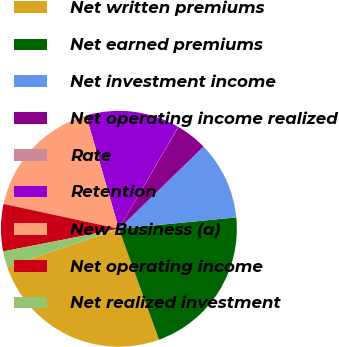<chart> <loc_0><loc_0><loc_500><loc_500><pie_chart><fcel>Net written premiums<fcel>Net earned premiums<fcel>Net investment income<fcel>Net operating income realized<fcel>Rate<fcel>Retention<fcel>New Business (a)<fcel>Net operating income<fcel>Net realized investment<nl><fcel>25.29%<fcel>21.01%<fcel>10.73%<fcel>4.31%<fcel>0.03%<fcel>12.87%<fcel>17.15%<fcel>6.45%<fcel>2.17%<nl></chart> 